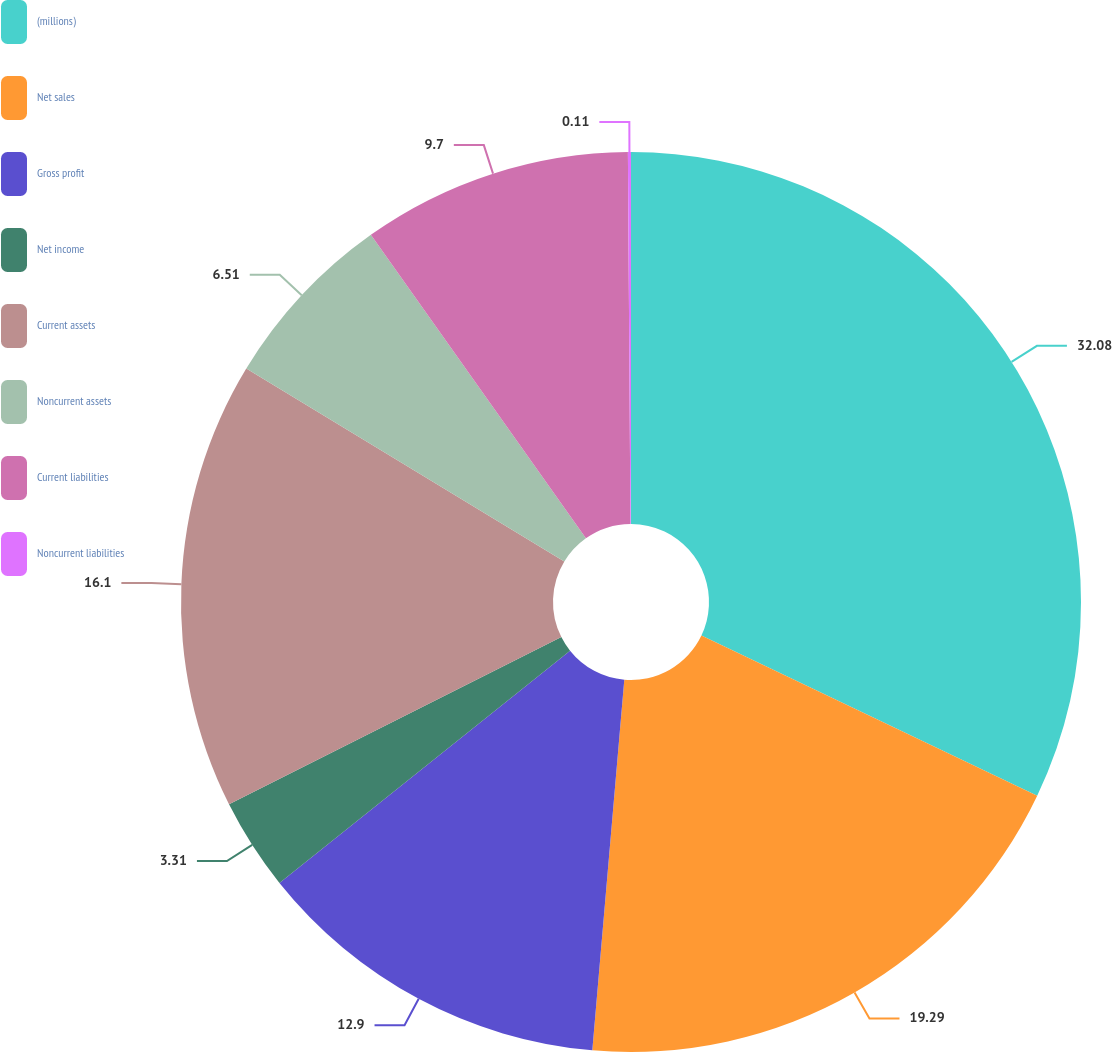Convert chart. <chart><loc_0><loc_0><loc_500><loc_500><pie_chart><fcel>(millions)<fcel>Net sales<fcel>Gross profit<fcel>Net income<fcel>Current assets<fcel>Noncurrent assets<fcel>Current liabilities<fcel>Noncurrent liabilities<nl><fcel>32.08%<fcel>19.29%<fcel>12.9%<fcel>3.31%<fcel>16.1%<fcel>6.51%<fcel>9.7%<fcel>0.11%<nl></chart> 